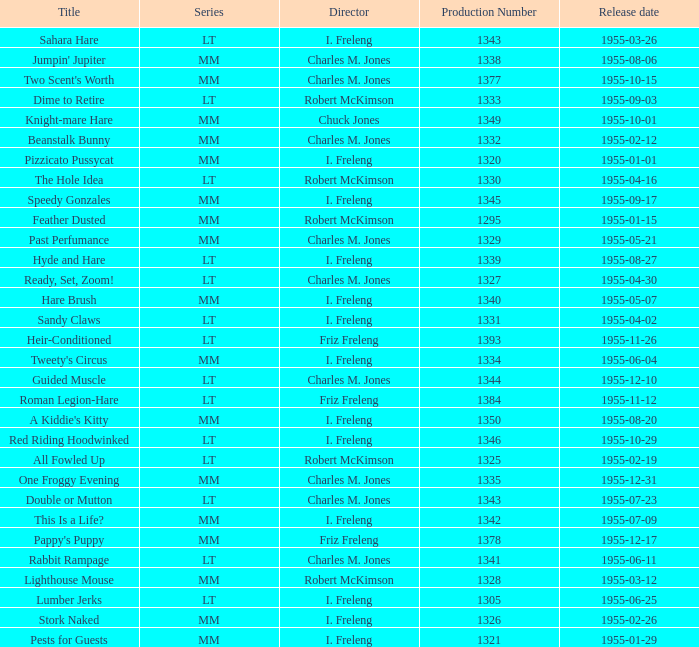What is the highest production number released on 1955-04-02 with i. freleng as the director? 1331.0. 